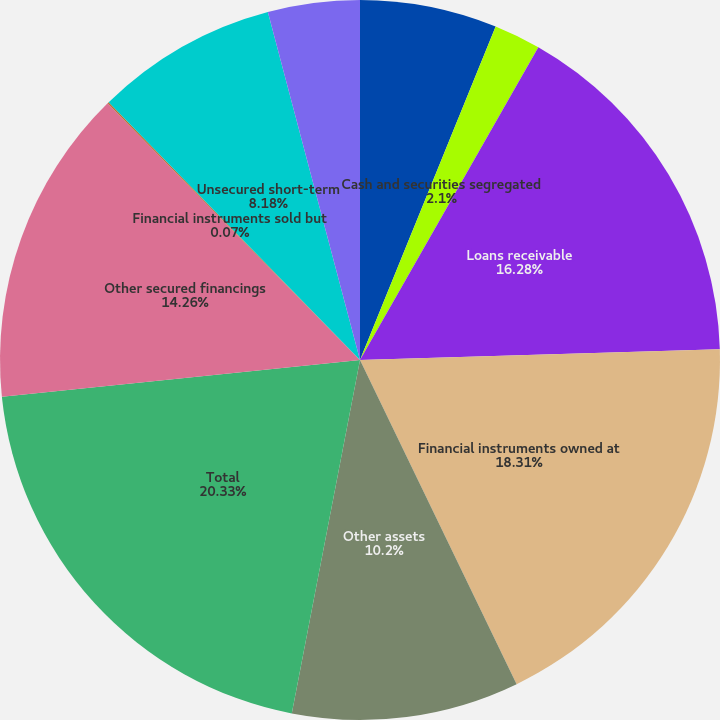<chart> <loc_0><loc_0><loc_500><loc_500><pie_chart><fcel>Cash and cash equivalents<fcel>Cash and securities segregated<fcel>Loans receivable<fcel>Financial instruments owned at<fcel>Other assets<fcel>Total<fcel>Other secured financings<fcel>Financial instruments sold but<fcel>Unsecured short-term<fcel>Unsecured long-term borrowings<nl><fcel>6.15%<fcel>2.1%<fcel>16.28%<fcel>18.31%<fcel>10.2%<fcel>20.34%<fcel>14.26%<fcel>0.07%<fcel>8.18%<fcel>4.12%<nl></chart> 